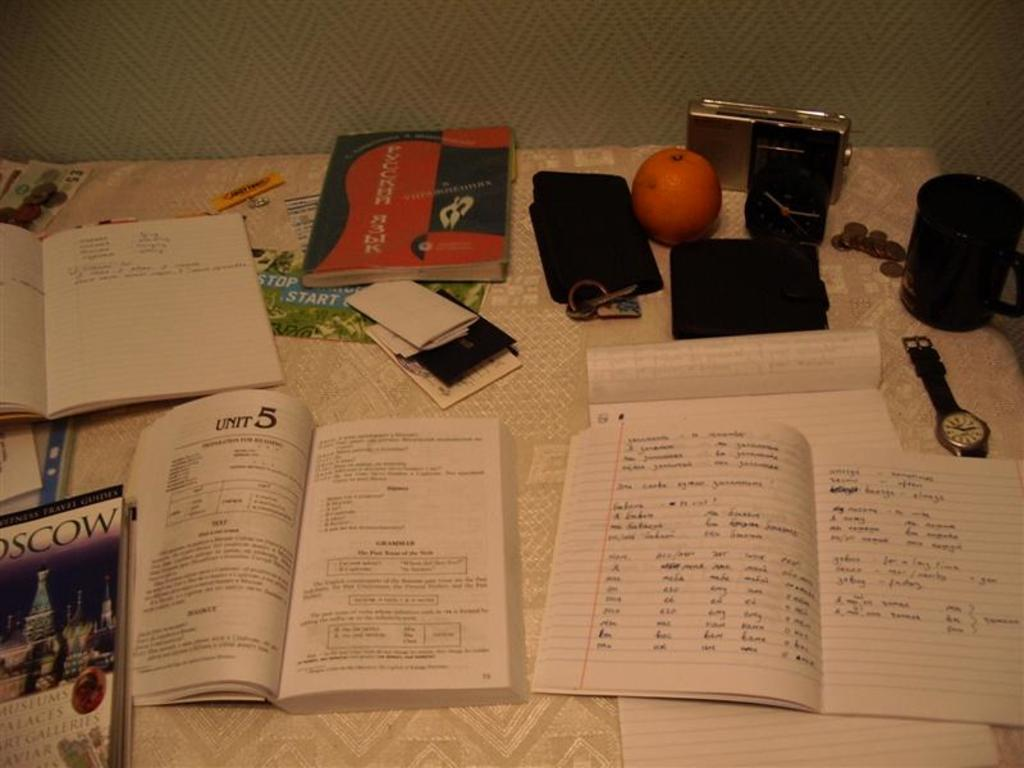<image>
Write a terse but informative summary of the picture. A school textbook is open to a section titled Unit 5. 